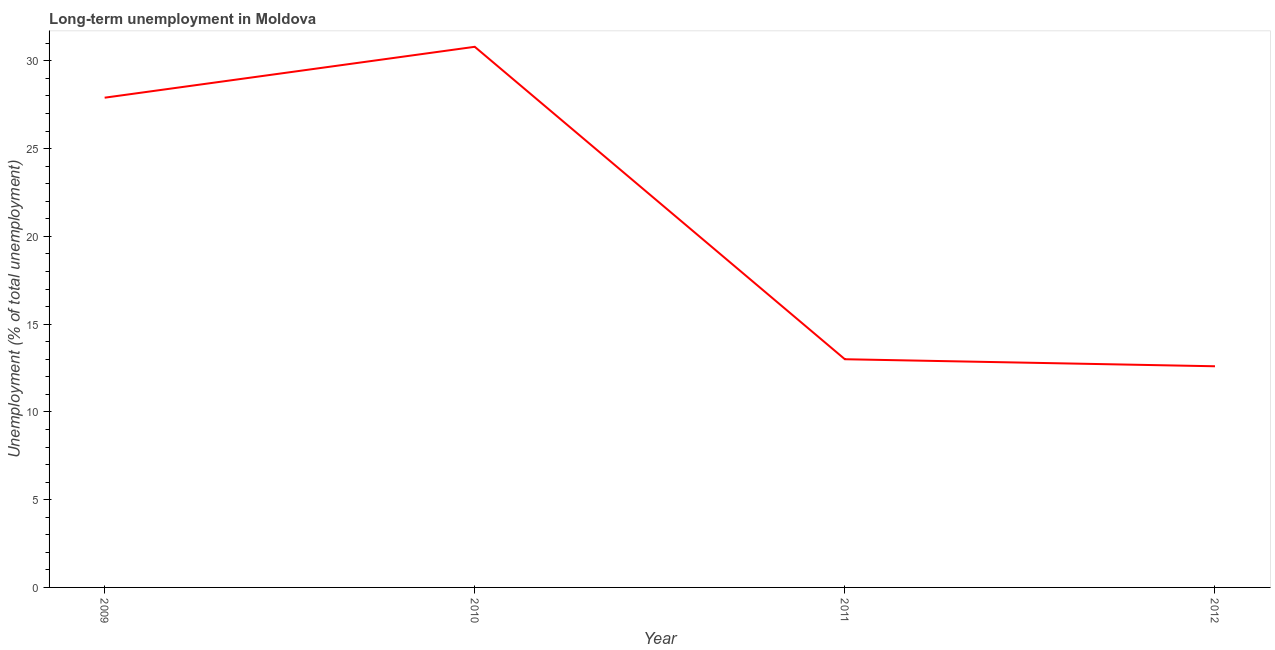What is the long-term unemployment in 2009?
Provide a succinct answer. 27.9. Across all years, what is the maximum long-term unemployment?
Make the answer very short. 30.8. Across all years, what is the minimum long-term unemployment?
Your response must be concise. 12.6. In which year was the long-term unemployment minimum?
Offer a terse response. 2012. What is the sum of the long-term unemployment?
Offer a terse response. 84.3. What is the difference between the long-term unemployment in 2009 and 2011?
Provide a short and direct response. 14.9. What is the average long-term unemployment per year?
Your response must be concise. 21.07. What is the median long-term unemployment?
Your response must be concise. 20.45. In how many years, is the long-term unemployment greater than 5 %?
Provide a succinct answer. 4. Do a majority of the years between 2011 and 2012 (inclusive) have long-term unemployment greater than 8 %?
Offer a terse response. Yes. What is the ratio of the long-term unemployment in 2010 to that in 2012?
Your answer should be compact. 2.44. What is the difference between the highest and the second highest long-term unemployment?
Keep it short and to the point. 2.9. What is the difference between the highest and the lowest long-term unemployment?
Make the answer very short. 18.2. How many lines are there?
Give a very brief answer. 1. Does the graph contain any zero values?
Your response must be concise. No. What is the title of the graph?
Provide a short and direct response. Long-term unemployment in Moldova. What is the label or title of the X-axis?
Provide a succinct answer. Year. What is the label or title of the Y-axis?
Make the answer very short. Unemployment (% of total unemployment). What is the Unemployment (% of total unemployment) of 2009?
Ensure brevity in your answer.  27.9. What is the Unemployment (% of total unemployment) in 2010?
Provide a succinct answer. 30.8. What is the Unemployment (% of total unemployment) of 2012?
Provide a short and direct response. 12.6. What is the difference between the Unemployment (% of total unemployment) in 2009 and 2012?
Your response must be concise. 15.3. What is the ratio of the Unemployment (% of total unemployment) in 2009 to that in 2010?
Provide a short and direct response. 0.91. What is the ratio of the Unemployment (% of total unemployment) in 2009 to that in 2011?
Keep it short and to the point. 2.15. What is the ratio of the Unemployment (% of total unemployment) in 2009 to that in 2012?
Your answer should be compact. 2.21. What is the ratio of the Unemployment (% of total unemployment) in 2010 to that in 2011?
Offer a very short reply. 2.37. What is the ratio of the Unemployment (% of total unemployment) in 2010 to that in 2012?
Make the answer very short. 2.44. What is the ratio of the Unemployment (% of total unemployment) in 2011 to that in 2012?
Provide a short and direct response. 1.03. 